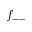<formula> <loc_0><loc_0><loc_500><loc_500>f _ { - - }</formula> 